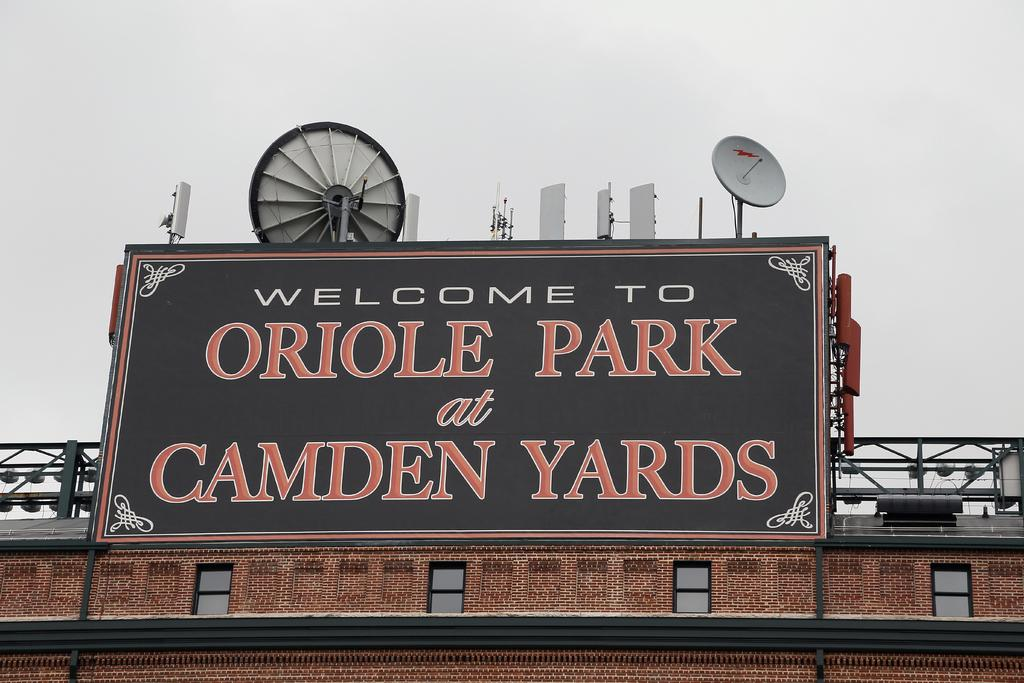<image>
Render a clear and concise summary of the photo. a big billboard sign that reads Welcome to Oriole Park 